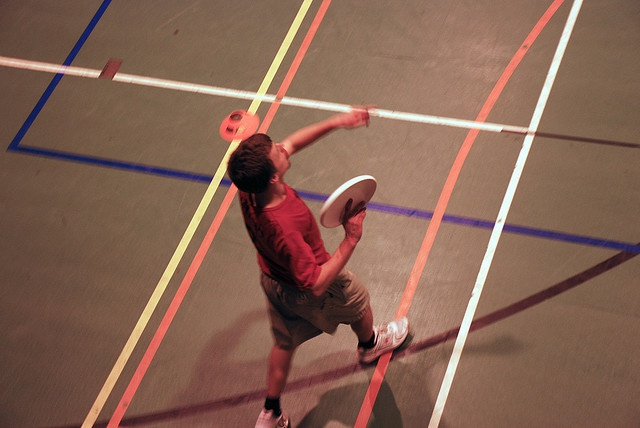Describe the objects in this image and their specific colors. I can see people in maroon, black, and brown tones and frisbee in maroon, brown, and white tones in this image. 